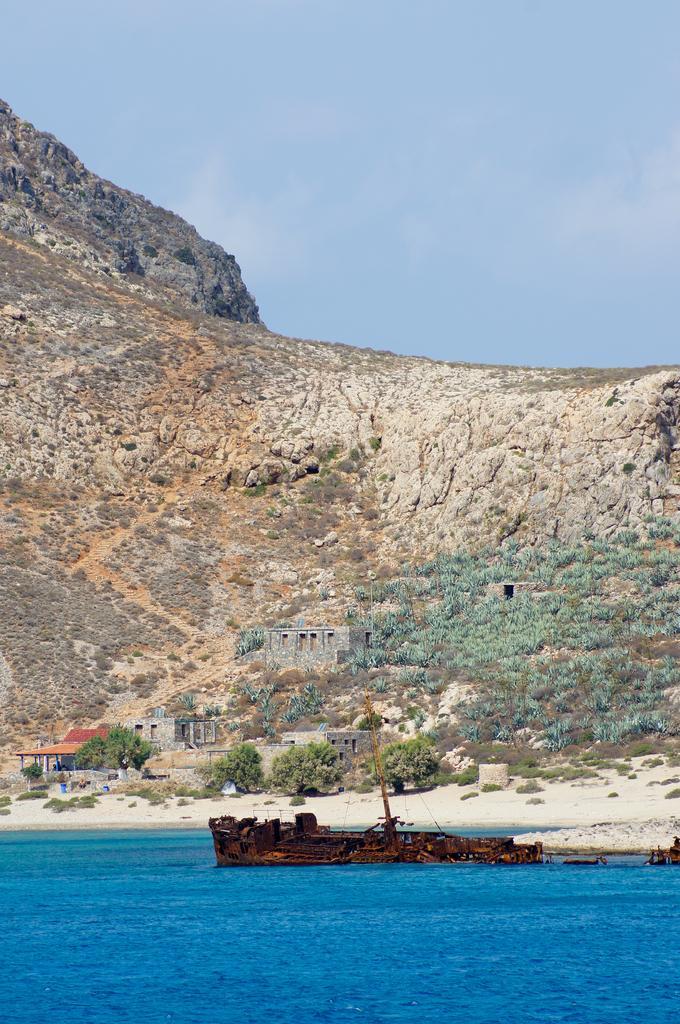Describe this image in one or two sentences. At the bottom of the image there is water with ship. Behind the water there is land with small plants. And also there are few buildings. And there is a hill with trees. At the top of the image there is sky. 